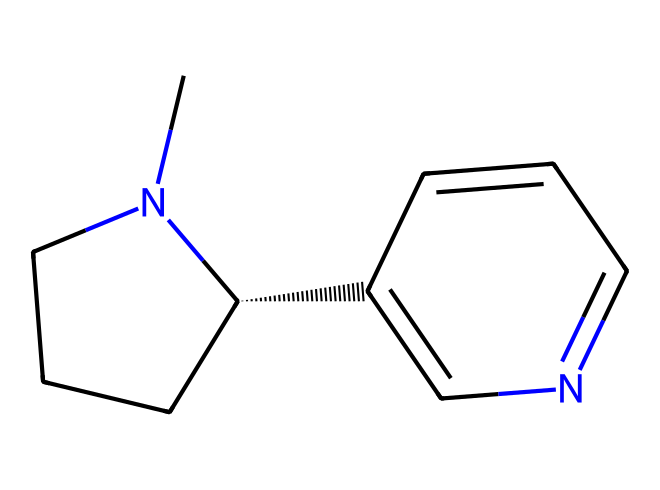What is the main functional group in this chemical structure? The chemical structure contains a nitrogen atom, which indicates that it has an amine functional group. This is a characteristic feature of nicotine.
Answer: amine How many carbons are in the structure of nicotine? By counting the carbon atoms represented in the SMILES string, there are 10 carbon atoms present in the nicotine molecule.
Answer: 10 What type of bonds are primarily found in this chemical structure? The majority of the bonds in this structure are carbon-carbon (C-C) and carbon-nitrogen (C-N) single bonds. The presence of rings also indicates some carbon-carbon double bonds.
Answer: single and double bonds How many rings are present in the nicotine structure? Examining the SMILES representation, there are two interconnected rings present in the nicotine structure.
Answer: 2 What does the presence of nitrogen in this hydrocarbon indicate about its properties? The presence of nitrogen in nicotine suggests it is an alkaloid, which often contributes to its pharmacological effects such as stimulating and addictive properties.
Answer: alkaloid 